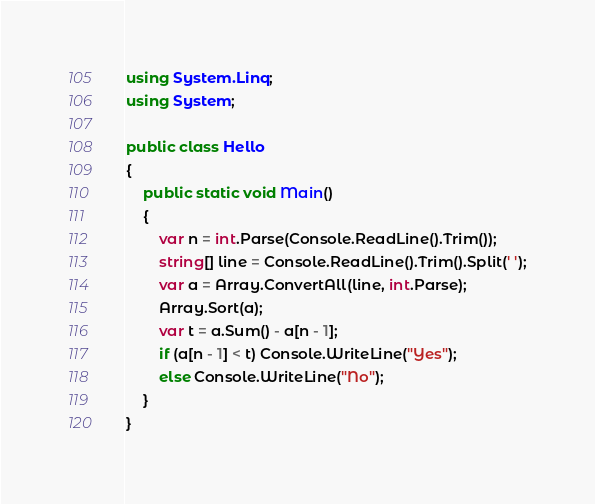Convert code to text. <code><loc_0><loc_0><loc_500><loc_500><_C#_>using System.Linq;
using System;

public class Hello
{
    public static void Main()
    {
        var n = int.Parse(Console.ReadLine().Trim());
        string[] line = Console.ReadLine().Trim().Split(' ');
        var a = Array.ConvertAll(line, int.Parse);
        Array.Sort(a);
        var t = a.Sum() - a[n - 1];
        if (a[n - 1] < t) Console.WriteLine("Yes");
        else Console.WriteLine("No");
    }
}</code> 